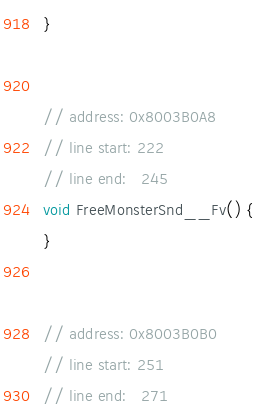<code> <loc_0><loc_0><loc_500><loc_500><_C++_>}


// address: 0x8003B0A8
// line start: 222
// line end:   245
void FreeMonsterSnd__Fv() {
}


// address: 0x8003B0B0
// line start: 251
// line end:   271</code> 